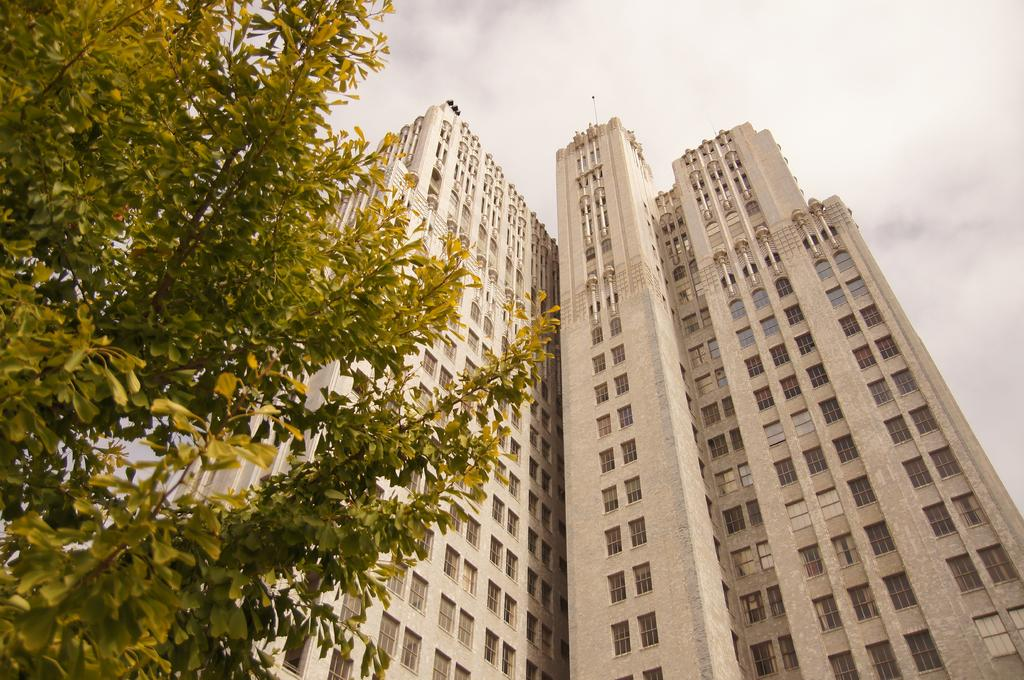What type of structures can be seen in the image? There are buildings in the image. What part of the natural environment is visible in the image? Sky is visible on the left side and at the top of the image. How many areas of the sky can be seen in the image? There are two areas of the sky visible in the image. What type of spark can be seen coming from the buildings in the image? There is no spark present in the image; it features buildings and visible sky. What role does the servant play in the image? There is no servant present in the image. 